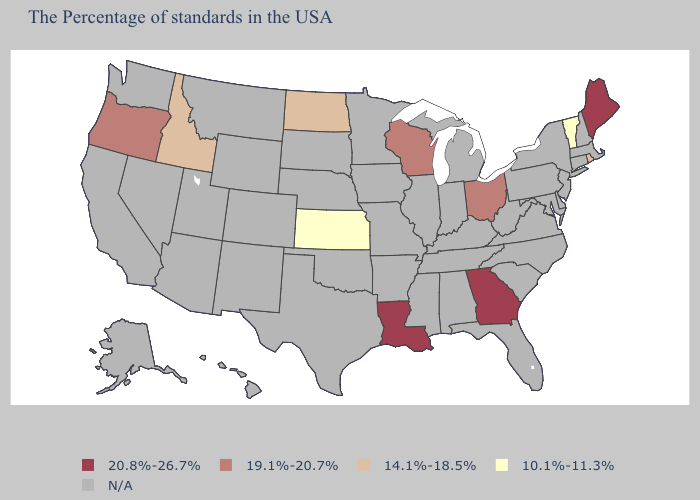Does Maine have the highest value in the Northeast?
Be succinct. Yes. Does the first symbol in the legend represent the smallest category?
Be succinct. No. What is the highest value in the USA?
Keep it brief. 20.8%-26.7%. What is the highest value in the Northeast ?
Write a very short answer. 20.8%-26.7%. Name the states that have a value in the range 20.8%-26.7%?
Give a very brief answer. Maine, Georgia, Louisiana. What is the value of North Carolina?
Be succinct. N/A. What is the value of Alaska?
Short answer required. N/A. Does the first symbol in the legend represent the smallest category?
Quick response, please. No. What is the value of Kentucky?
Give a very brief answer. N/A. What is the highest value in the USA?
Concise answer only. 20.8%-26.7%. What is the lowest value in states that border Nevada?
Concise answer only. 14.1%-18.5%. Does Vermont have the highest value in the Northeast?
Keep it brief. No. 